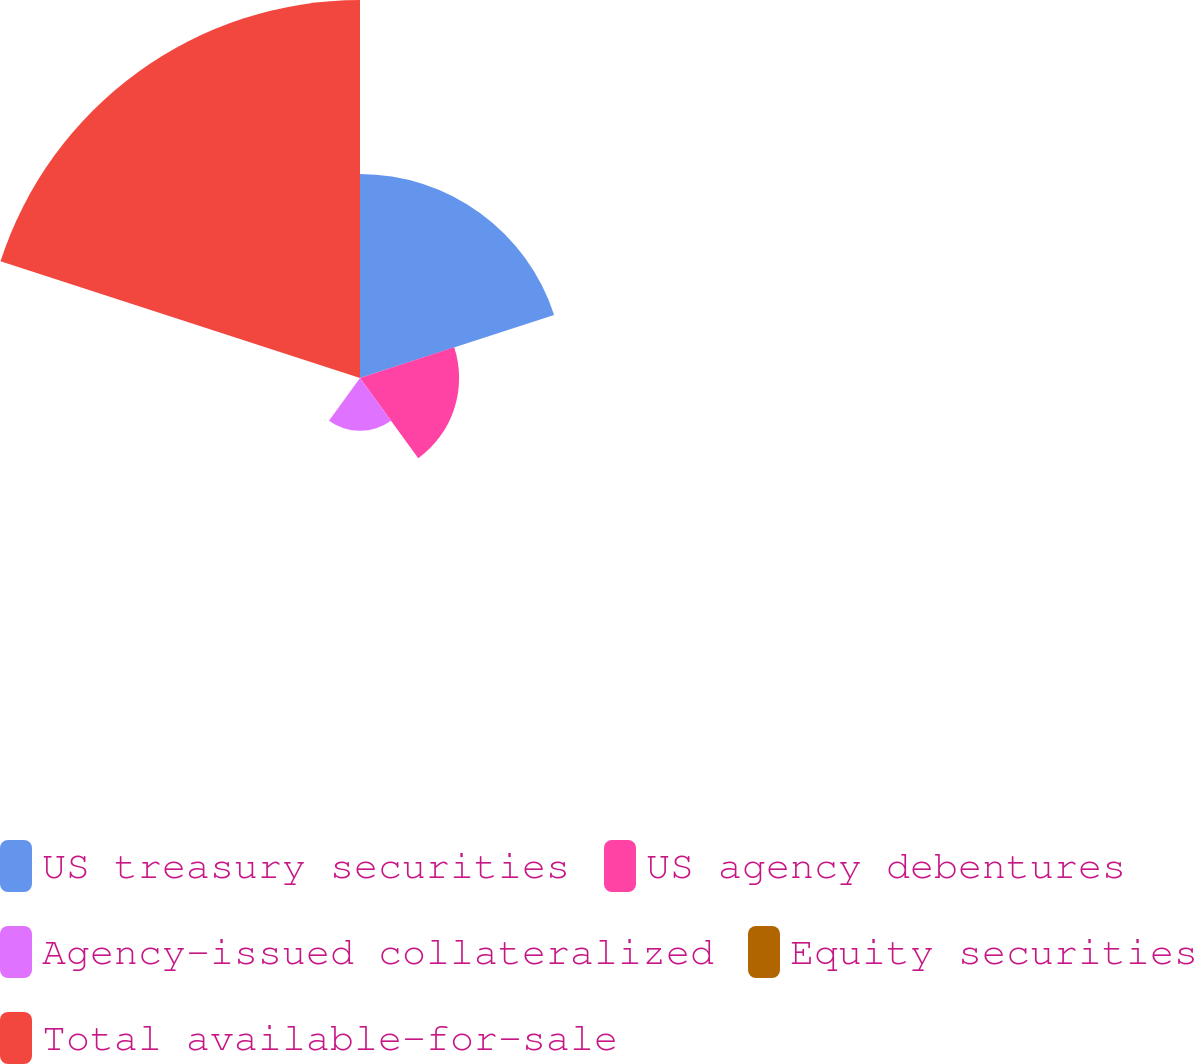Convert chart. <chart><loc_0><loc_0><loc_500><loc_500><pie_chart><fcel>US treasury securities<fcel>US agency debentures<fcel>Agency-issued collateralized<fcel>Equity securities<fcel>Total available-for-sale<nl><fcel>27.8%<fcel>13.5%<fcel>7.19%<fcel>0.02%<fcel>51.49%<nl></chart> 